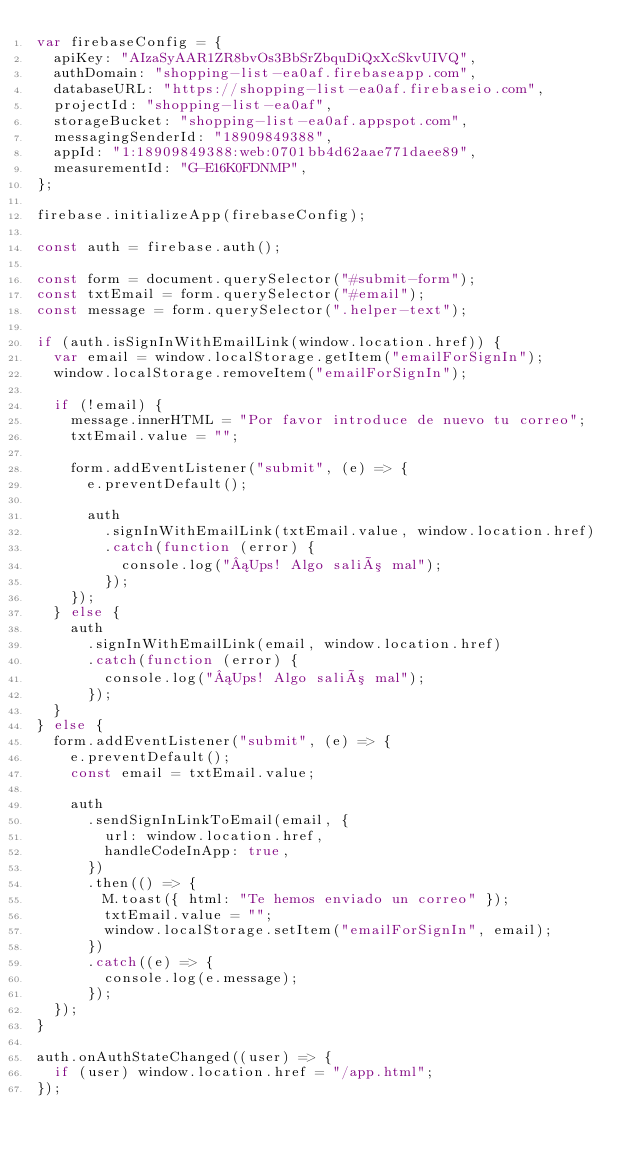Convert code to text. <code><loc_0><loc_0><loc_500><loc_500><_JavaScript_>var firebaseConfig = {
  apiKey: "AIzaSyAAR1ZR8bvOs3BbSrZbquDiQxXcSkvUIVQ",
  authDomain: "shopping-list-ea0af.firebaseapp.com",
  databaseURL: "https://shopping-list-ea0af.firebaseio.com",
  projectId: "shopping-list-ea0af",
  storageBucket: "shopping-list-ea0af.appspot.com",
  messagingSenderId: "18909849388",
  appId: "1:18909849388:web:0701bb4d62aae771daee89",
  measurementId: "G-E16K0FDNMP",
};

firebase.initializeApp(firebaseConfig);

const auth = firebase.auth();

const form = document.querySelector("#submit-form");
const txtEmail = form.querySelector("#email");
const message = form.querySelector(".helper-text");

if (auth.isSignInWithEmailLink(window.location.href)) {
  var email = window.localStorage.getItem("emailForSignIn");
  window.localStorage.removeItem("emailForSignIn");

  if (!email) {
    message.innerHTML = "Por favor introduce de nuevo tu correo";
    txtEmail.value = "";

    form.addEventListener("submit", (e) => {
      e.preventDefault();

      auth
        .signInWithEmailLink(txtEmail.value, window.location.href)
        .catch(function (error) {
          console.log("¡Ups! Algo salió mal");
        });
    });
  } else {
    auth
      .signInWithEmailLink(email, window.location.href)
      .catch(function (error) {
        console.log("¡Ups! Algo salió mal");
      });
  }
} else {
  form.addEventListener("submit", (e) => {
    e.preventDefault();
    const email = txtEmail.value;

    auth
      .sendSignInLinkToEmail(email, {
        url: window.location.href,
        handleCodeInApp: true,
      })
      .then(() => {
        M.toast({ html: "Te hemos enviado un correo" });
        txtEmail.value = "";
        window.localStorage.setItem("emailForSignIn", email);
      })
      .catch((e) => {
        console.log(e.message);
      });
  });
}

auth.onAuthStateChanged((user) => {
  if (user) window.location.href = "/app.html";
});
</code> 